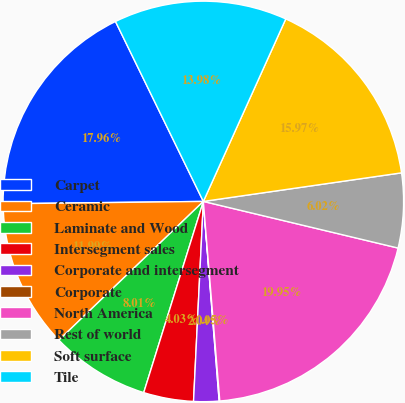Convert chart to OTSL. <chart><loc_0><loc_0><loc_500><loc_500><pie_chart><fcel>Carpet<fcel>Ceramic<fcel>Laminate and Wood<fcel>Intersegment sales<fcel>Corporate and intersegment<fcel>Corporate<fcel>North America<fcel>Rest of world<fcel>Soft surface<fcel>Tile<nl><fcel>17.96%<fcel>11.99%<fcel>8.01%<fcel>4.03%<fcel>2.04%<fcel>0.05%<fcel>19.95%<fcel>6.02%<fcel>15.97%<fcel>13.98%<nl></chart> 